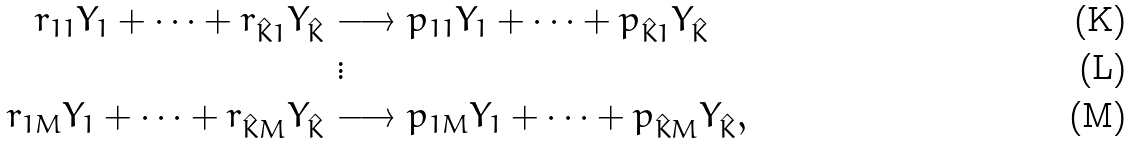Convert formula to latex. <formula><loc_0><loc_0><loc_500><loc_500>r _ { 1 1 } Y _ { 1 } + \dots + r _ { \hat { K } 1 } Y _ { \hat { K } } \ & { \longrightarrow } \ p _ { 1 1 } Y _ { 1 } + \dots + p _ { \hat { K } 1 } Y _ { \hat { K } } \\ & \vdots \\ r _ { 1 M } Y _ { 1 } + \dots + r _ { \hat { K } M } Y _ { \hat { K } } \ & { \longrightarrow } \ p _ { 1 M } Y _ { 1 } + \dots + p _ { \hat { K } M } Y _ { \hat { K } } ,</formula> 